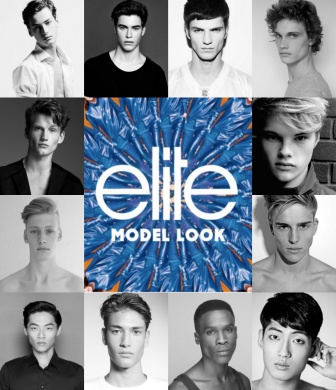If this image were to come alive, what kind of story would it tell? If the image were to come alive, it would tell the story of a diverse group of aspiring models, each with their own journey and dreams. They come from different backgrounds and paths, converging at the Elite Model Look competition. Their collective story is one of perseverance, hard work, and the pursuit of personal and professional growth in the competitive world of modeling. The vibrant central logo acts as a beacon of hope and ambition, representing the unity and shared aspirations of these individuals. 